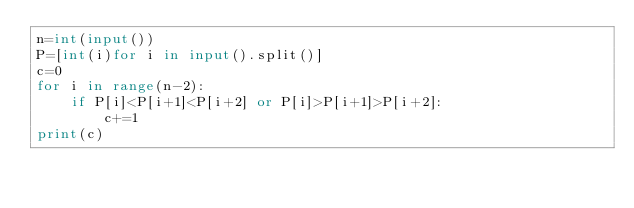<code> <loc_0><loc_0><loc_500><loc_500><_Python_>n=int(input())
P=[int(i)for i in input().split()]
c=0
for i in range(n-2):
    if P[i]<P[i+1]<P[i+2] or P[i]>P[i+1]>P[i+2]:
        c+=1
print(c)</code> 